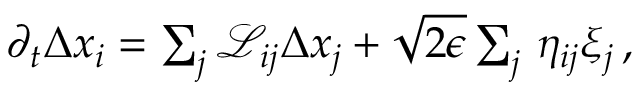Convert formula to latex. <formula><loc_0><loc_0><loc_500><loc_500>\begin{array} { r } { \partial _ { t } { \Delta x } _ { i } = \sum _ { j } \mathcal { L } _ { i j } \Delta x _ { j } + \sqrt { 2 \epsilon } \sum _ { j } \, \eta _ { i j } \xi _ { j } \, , } \end{array}</formula> 